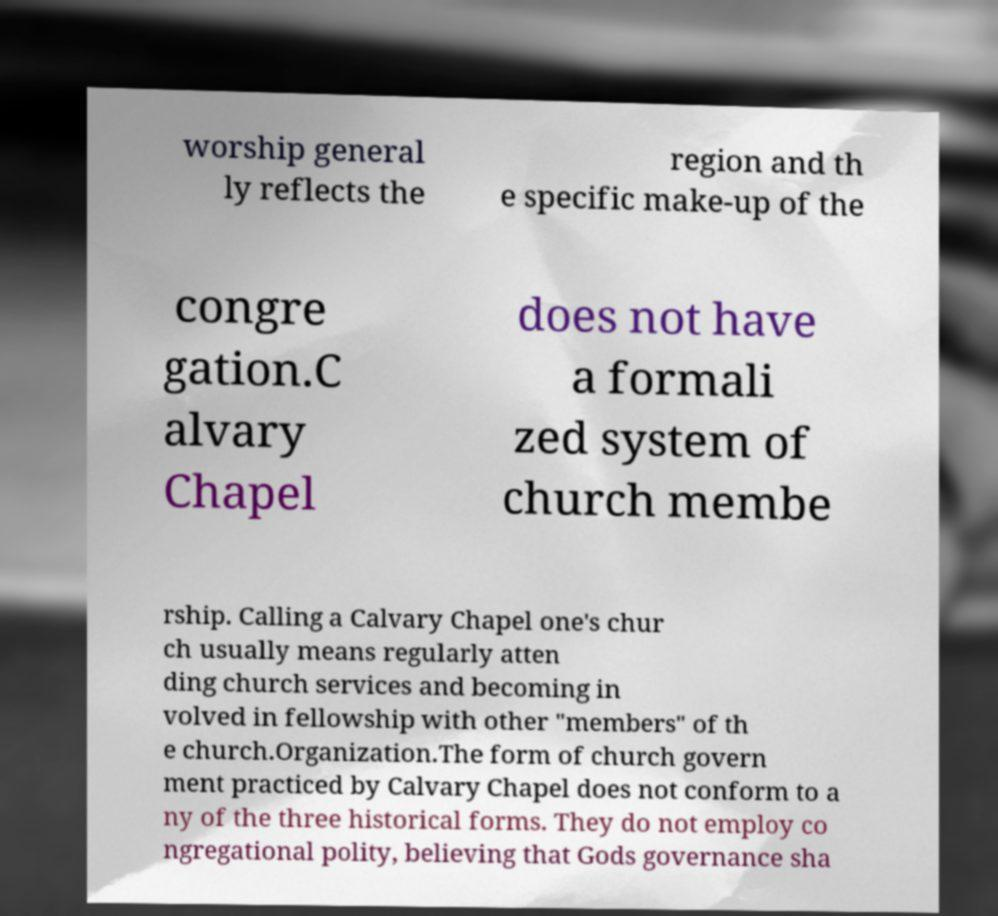There's text embedded in this image that I need extracted. Can you transcribe it verbatim? worship general ly reflects the region and th e specific make-up of the congre gation.C alvary Chapel does not have a formali zed system of church membe rship. Calling a Calvary Chapel one's chur ch usually means regularly atten ding church services and becoming in volved in fellowship with other "members" of th e church.Organization.The form of church govern ment practiced by Calvary Chapel does not conform to a ny of the three historical forms. They do not employ co ngregational polity, believing that Gods governance sha 